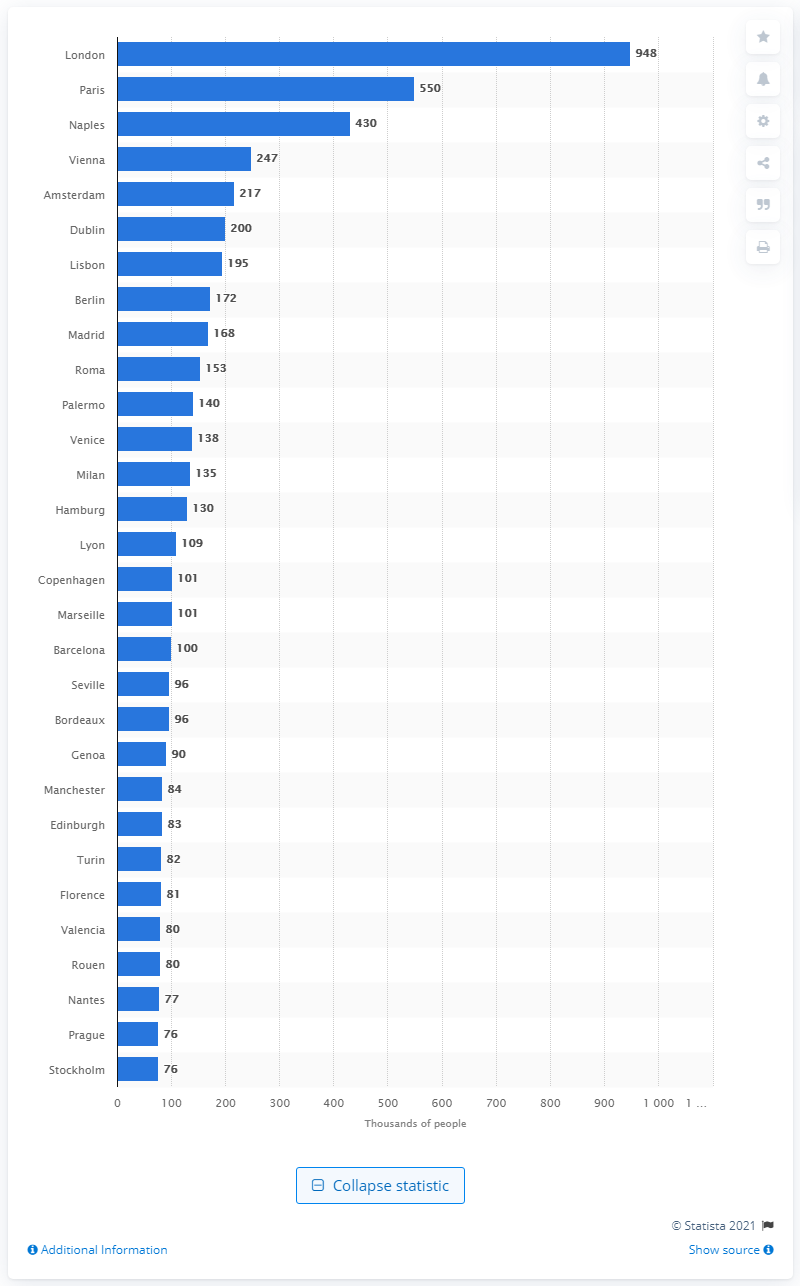Can you tell me more about the population distribution in top European cities around 1800 according to this chart? Certainly, the chart reveals that London had a significant lead in population size compared to other European cities around 1800, boasting nearly a million inhabitants. Paris was the second largest, with a population roughly half that of London, followed by the vibrant Italian city of Naples. Vienna, Amsterdam, and Dublin also feature as major urban centers, each showing the significance of their respective regions in terms of cultural and economic influence during that period. 